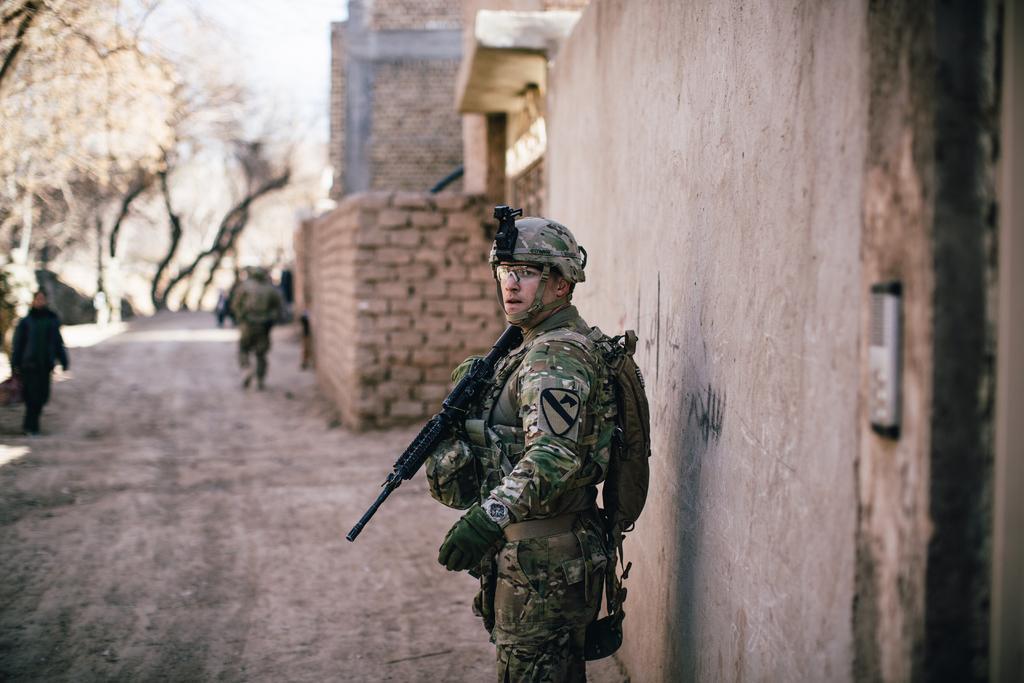Describe this image in one or two sentences. In the center of the image there is a person holding a gun. On the right side of the image we can see wall. In the background we can see building, trees, sky and persons. 